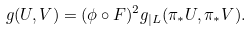<formula> <loc_0><loc_0><loc_500><loc_500>g ( U , V ) = ( \phi \circ F ) ^ { 2 } g _ { | { L } } ( \pi _ { * } U , \pi _ { * } V ) .</formula> 